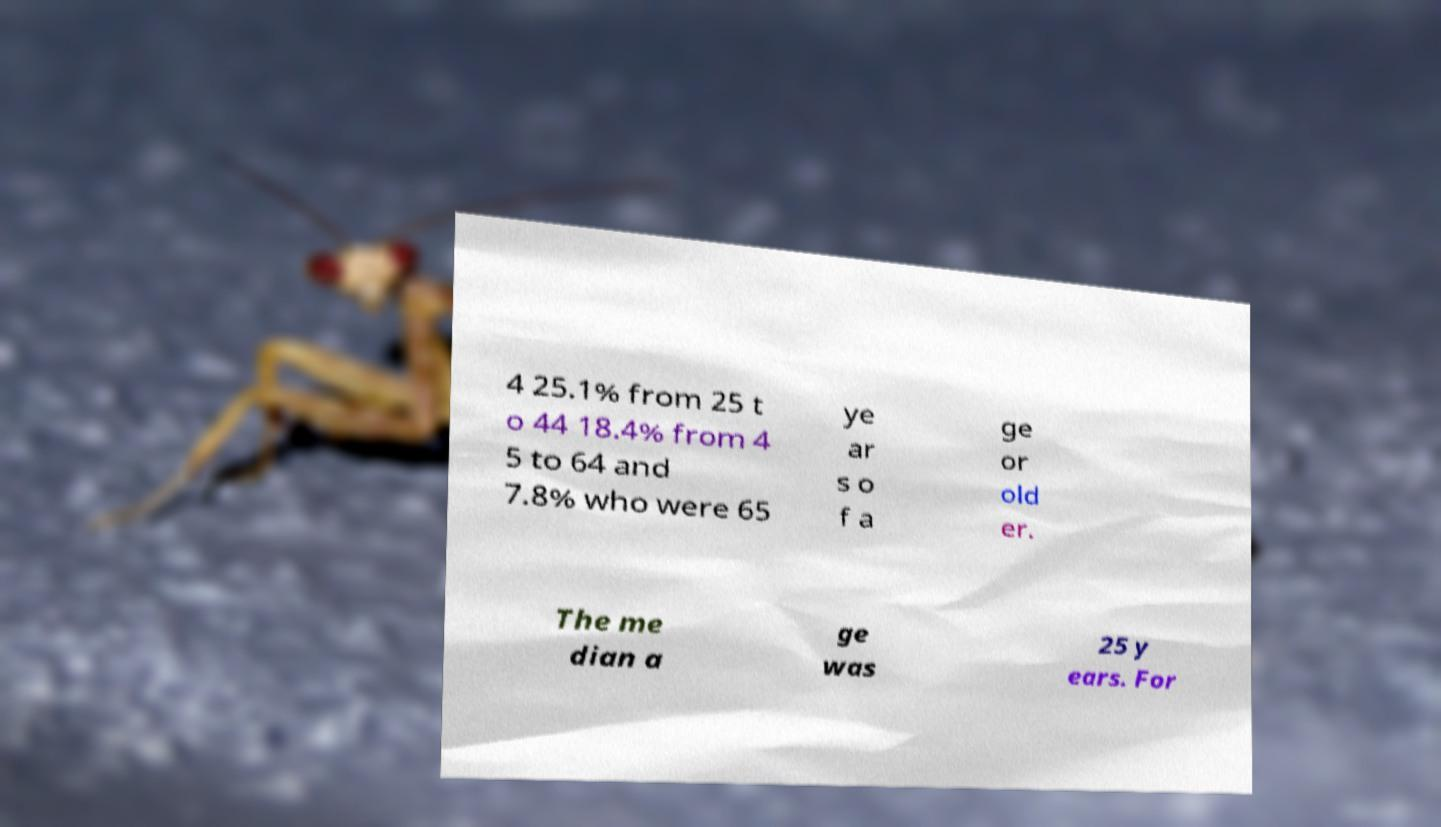For documentation purposes, I need the text within this image transcribed. Could you provide that? 4 25.1% from 25 t o 44 18.4% from 4 5 to 64 and 7.8% who were 65 ye ar s o f a ge or old er. The me dian a ge was 25 y ears. For 